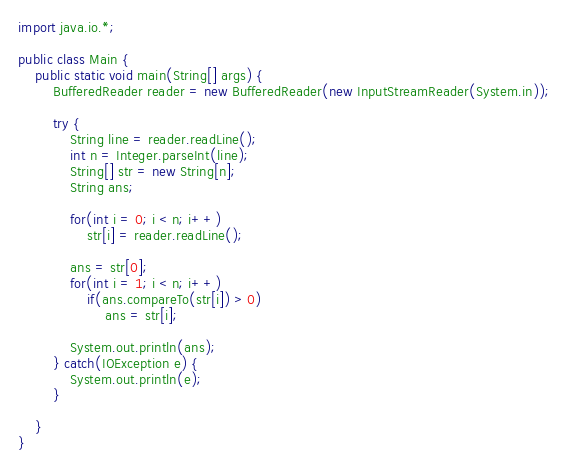Convert code to text. <code><loc_0><loc_0><loc_500><loc_500><_Java_>import java.io.*;

public class Main {
	public static void main(String[] args) {
		BufferedReader reader = new BufferedReader(new InputStreamReader(System.in));

		try {
			String line = reader.readLine();
			int n = Integer.parseInt(line);
			String[] str = new String[n];
			String ans;

			for(int i = 0; i < n; i++)
				str[i] = reader.readLine();

			ans = str[0];
			for(int i = 1; i < n; i++)
				if(ans.compareTo(str[i]) > 0)
					ans = str[i];

			System.out.println(ans);
		} catch(IOException e) {
			System.out.println(e);
		}

	}
}</code> 